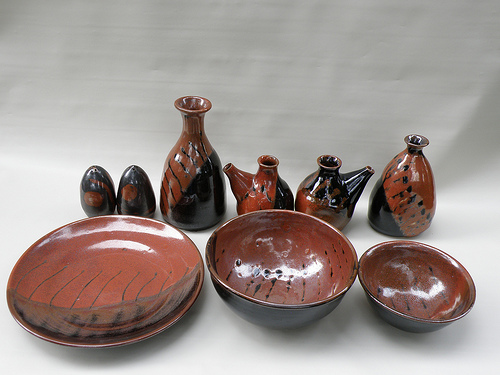Which item among these pottery pieces stands out the most and why? The item that stands out the most is the large central bowl with black streaks on the glaze. Its significant size and striking design draw the viewer's eye immediately, making it the focal point of the collection. The contrast between the deep red base and the bold black streaks creates a dynamic visual interest, highlighting the craftsmanship and aesthetic appeal. Considering practical usage, which item would be the most versatile? The medium-sized red and black bowls would likely be the most versatile items in this collection. Their size makes them suitable for a variety of uses, from serving soups and salads to holding fruits or even as decorative pieces. Their visually appealing design also means they can enhance the setting, whether used for functional purposes or as part of a display. 